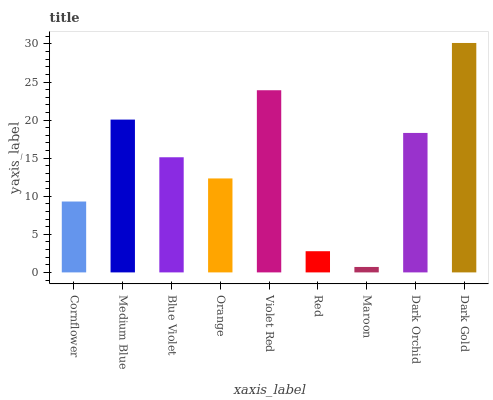Is Medium Blue the minimum?
Answer yes or no. No. Is Medium Blue the maximum?
Answer yes or no. No. Is Medium Blue greater than Cornflower?
Answer yes or no. Yes. Is Cornflower less than Medium Blue?
Answer yes or no. Yes. Is Cornflower greater than Medium Blue?
Answer yes or no. No. Is Medium Blue less than Cornflower?
Answer yes or no. No. Is Blue Violet the high median?
Answer yes or no. Yes. Is Blue Violet the low median?
Answer yes or no. Yes. Is Cornflower the high median?
Answer yes or no. No. Is Maroon the low median?
Answer yes or no. No. 